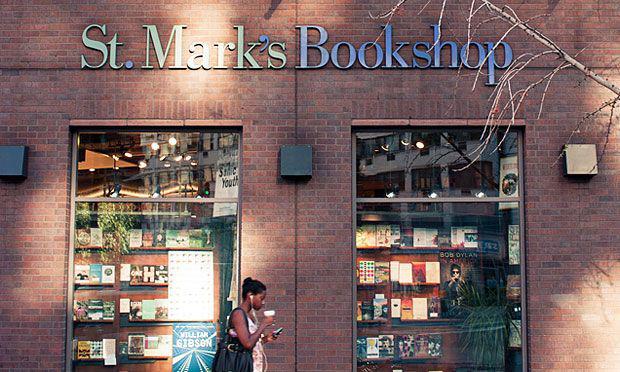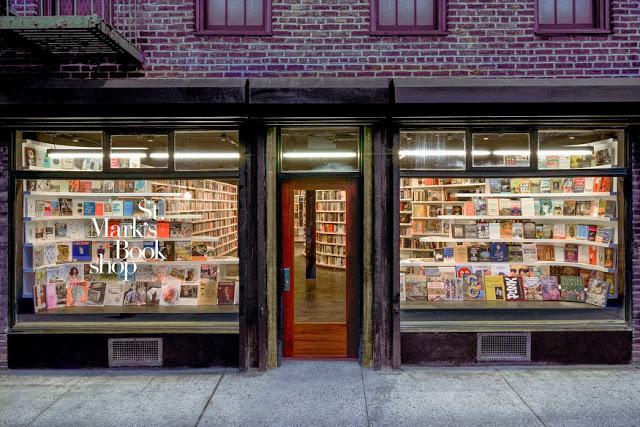The first image is the image on the left, the second image is the image on the right. For the images displayed, is the sentence "All photos show only the exterior facade of the building." factually correct? Answer yes or no. Yes. The first image is the image on the left, the second image is the image on the right. For the images shown, is this caption "There are people looking at and reading books" true? Answer yes or no. No. 